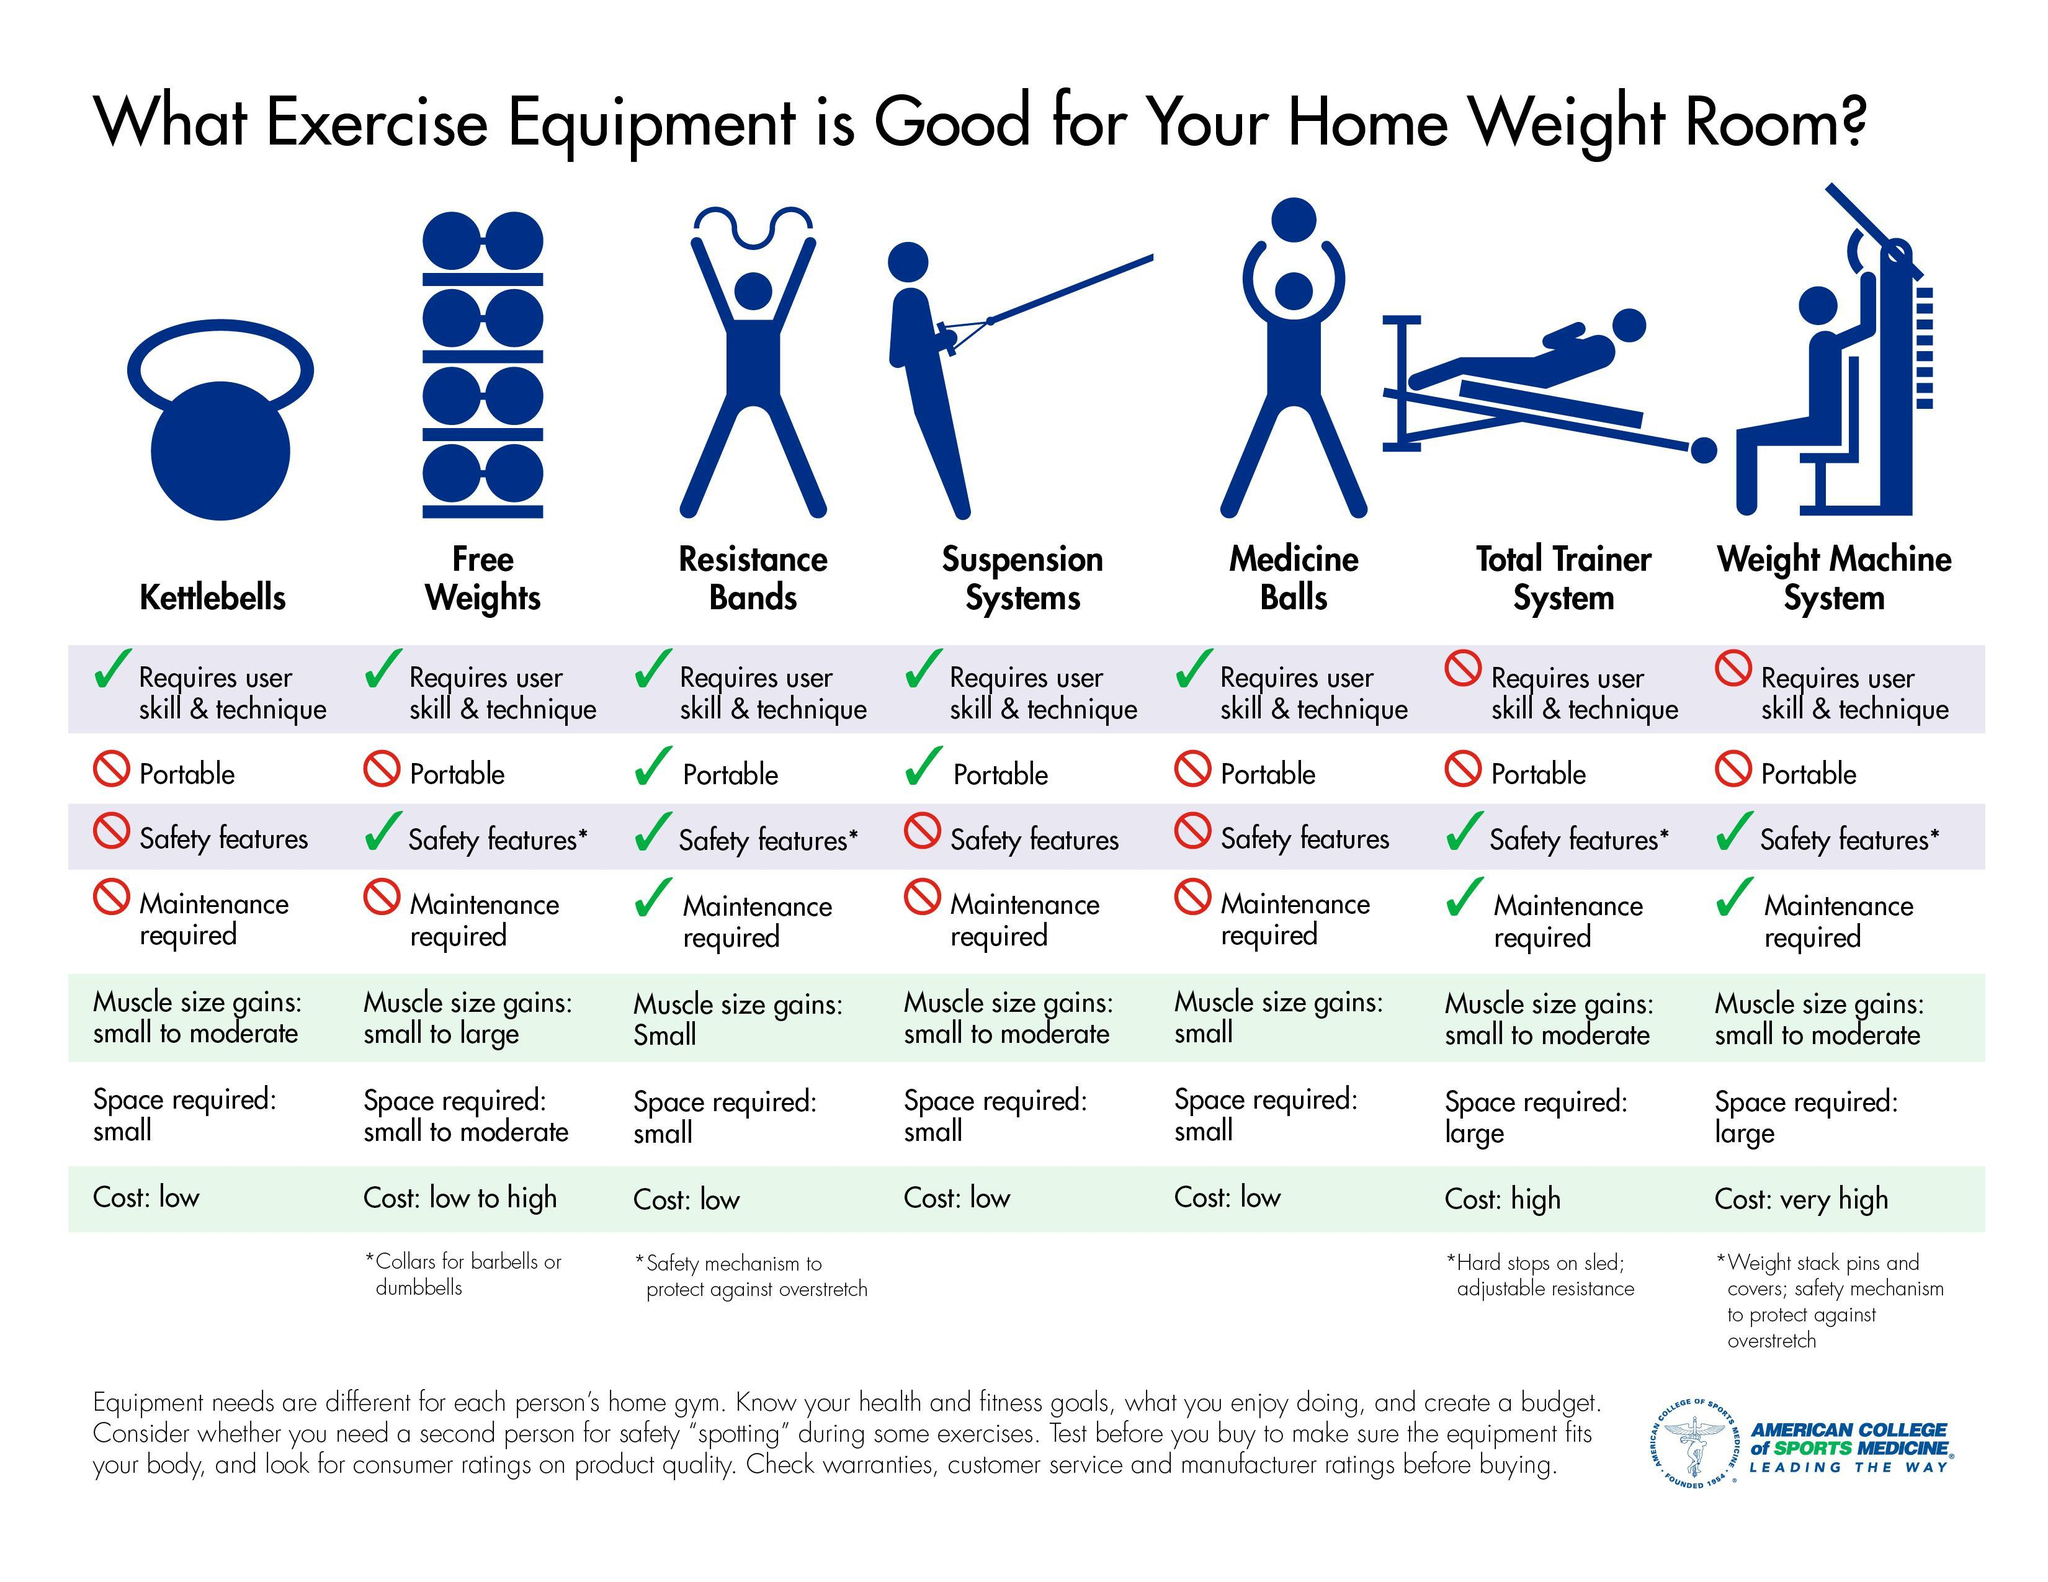Which two exercise equipments require maintenance other than the resistance bands?
Answer the question with a short phrase. Total Trainer System, Weight Machine System Which are the two portable exercise equipments good for the home weight room? Resistance Bands, Suspension Systems What type of exercise equipment used in the home weight room do not require user skill & technique? Total Trainer System, Weight Machine System 